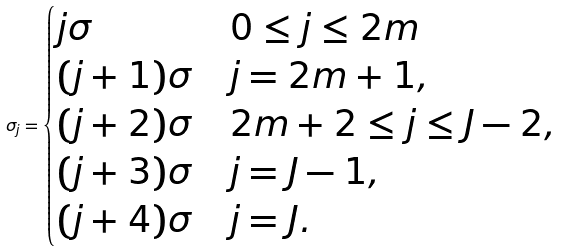<formula> <loc_0><loc_0><loc_500><loc_500>\sigma _ { j } = \begin{cases} j \sigma & 0 \leq j \leq 2 m \\ ( j + 1 ) \sigma & j = 2 m + 1 , \\ ( j + 2 ) \sigma & 2 m + 2 \leq j \leq J - 2 , \\ ( j + 3 ) \sigma & j = J - 1 , \\ ( j + 4 ) \sigma & j = J . \end{cases}</formula> 